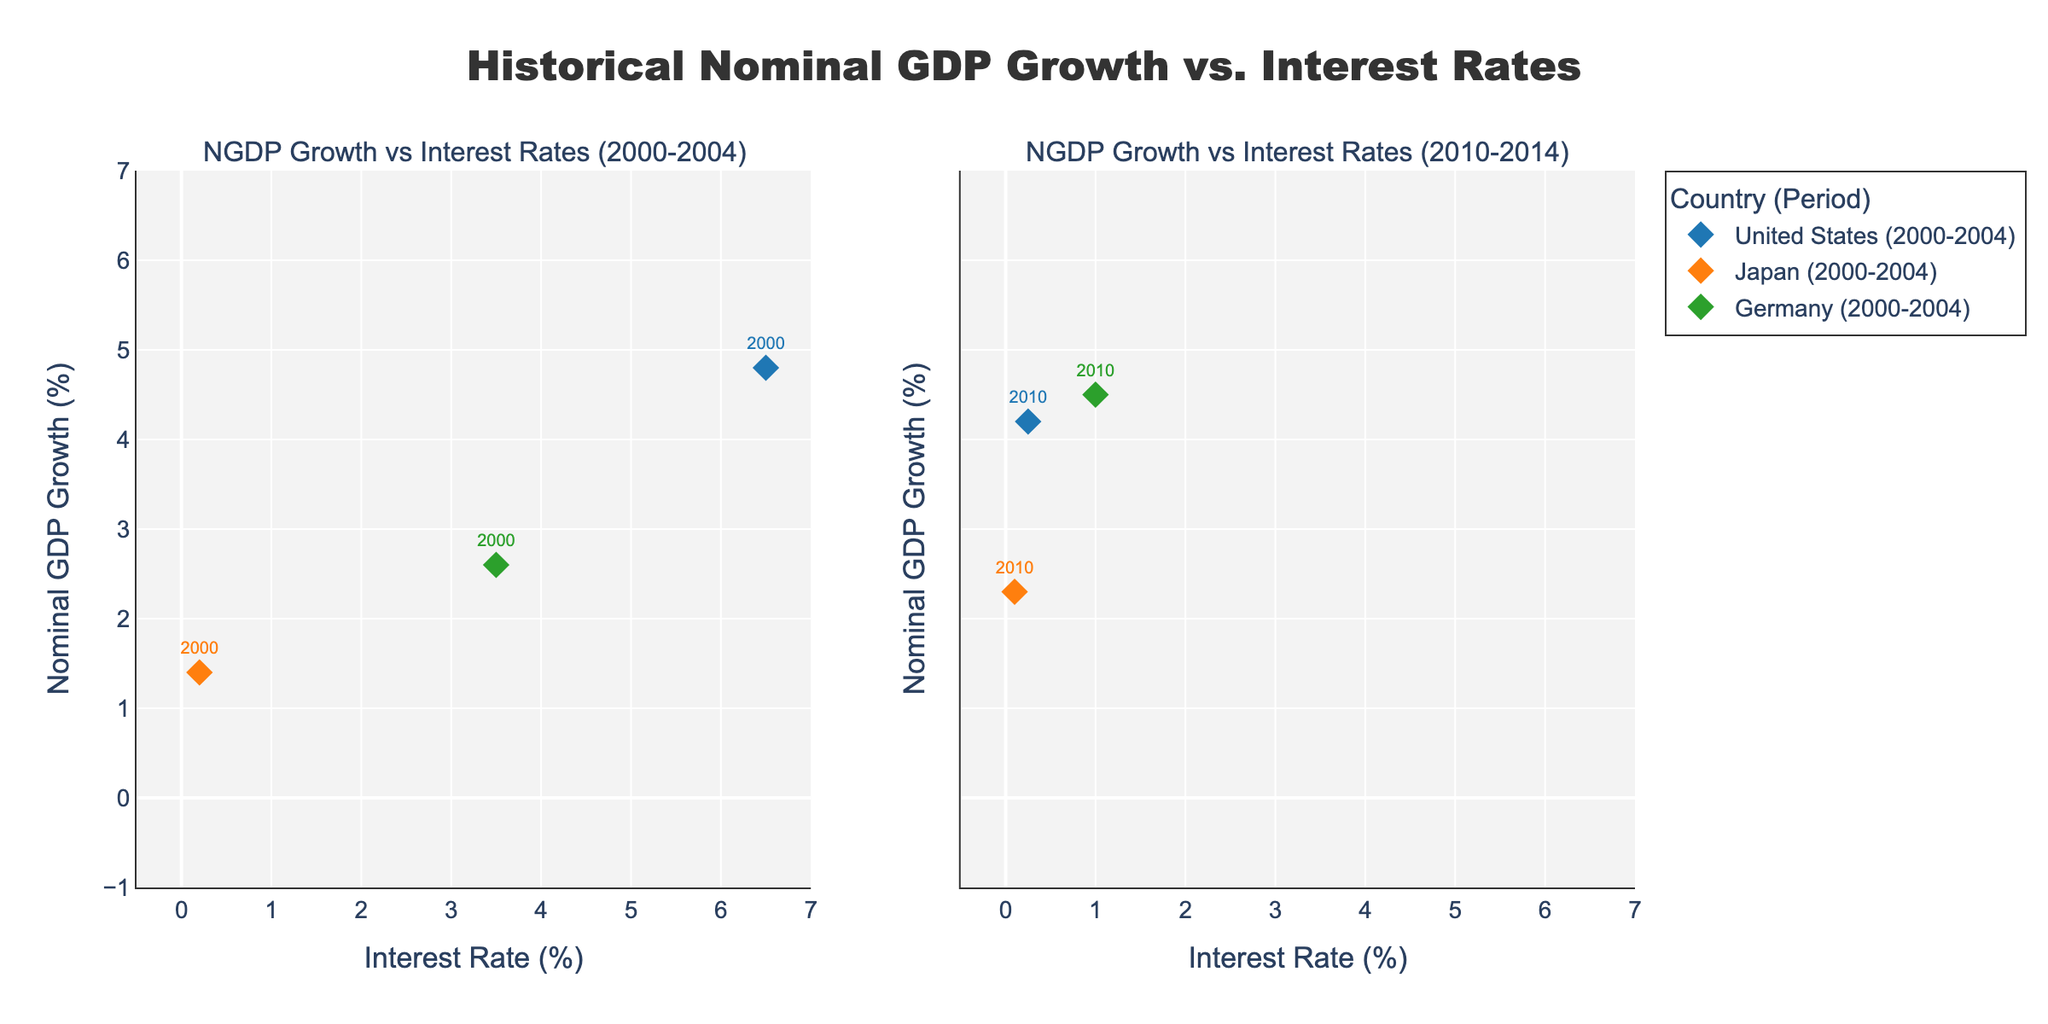What is the title of the left subplot? The left subplot covers the period from 2000 to 2004. The subplot is titled accordingly.
Answer: NGDP Growth vs Interest Rates (2000-2004) How many data points are for Germany in the right subplot? The right subplot covers the period from 2010 to 2014. For Germany, we count the years 2010, 2011, 2012, 2013, and 2014.
Answer: 5 Which country had the highest Nominal GDP Growth in the period 2010-2014? Looking at the markers' positions in the right subplot, the United States in 2011 and Germany in 2010 both have the highest NGDP Growth, which is the highest point on the Y-axis.
Answer: United States and Germany How does Japan's Nominal GDP Growth in 2001 compare to that in 2013? By looking at the vertical position of Japan's markers in both subplots for the years 2001 and 2013, we compare the two NGDP Growth values. Japan's NGDP Growth in 2001 is lower than in 2013.
Answer: Higher in 2013 On average, does the United States have higher interest rates in the period 2000-2004 compared to 2010-2014? Calculate the average interest rate for the United States in both periods. For 2000-2004: (6.5 + 3.5 + 1.7 + 1.2 + 1.9)/5 = 2.96. For 2010-2014: (0.25 + 0.25 + 0.25 + 0.25 + 0.25)/5 = 0.25.
Answer: Higher in 2000-2004 In which year did Germany have the lowest Nominal GDP Growth in the period 2000-2004? Look at the marker positions along the Y-axis for Germany in the left subplot. The lowest point indicates the year with the lowest NGDP Growth.
Answer: 2002 Compare the relationship between interest rates and Nominal GDP Growth for Japan in both periods. Look at the trend of Japan's markers in both subplots concerning interest rates and NGDP Growth. In both periods, Japan's Interest Rates were close to zero and had low but positive NGDP Growth rates.
Answer: Stable low interest rates, low NGDP Growth Which period shows a more consistent interest rate for the United States? Check the spread of the United States' markers along the X-axis in each subplot. The right subplot shows that the interest rates for all years are the same and very close to each other.
Answer: 2010-2014 What is the range of Nominal GDP Growth for Germany in the period 2000-2004? Identify the highest and lowest Nominal GDP Growth values for Germany in the left subplot. The highest is about 3.1%, and the lowest is about 0.1%.
Answer: 0.1% to 3.1% 